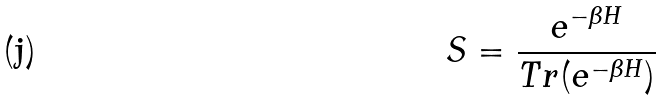Convert formula to latex. <formula><loc_0><loc_0><loc_500><loc_500>S = \frac { e ^ { - \beta H } } { T r ( e ^ { - \beta H } ) }</formula> 